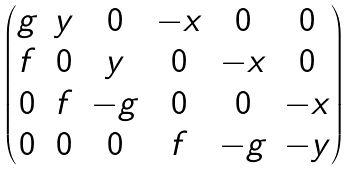Convert formula to latex. <formula><loc_0><loc_0><loc_500><loc_500>\begin{pmatrix} g & y & 0 & { - x } & 0 & 0 \\ f & 0 & y & 0 & { - x } & 0 \\ 0 & f & { - g } & 0 & 0 & { - x } \\ 0 & 0 & 0 & f & { - g } & { - y } \\ \end{pmatrix}</formula> 